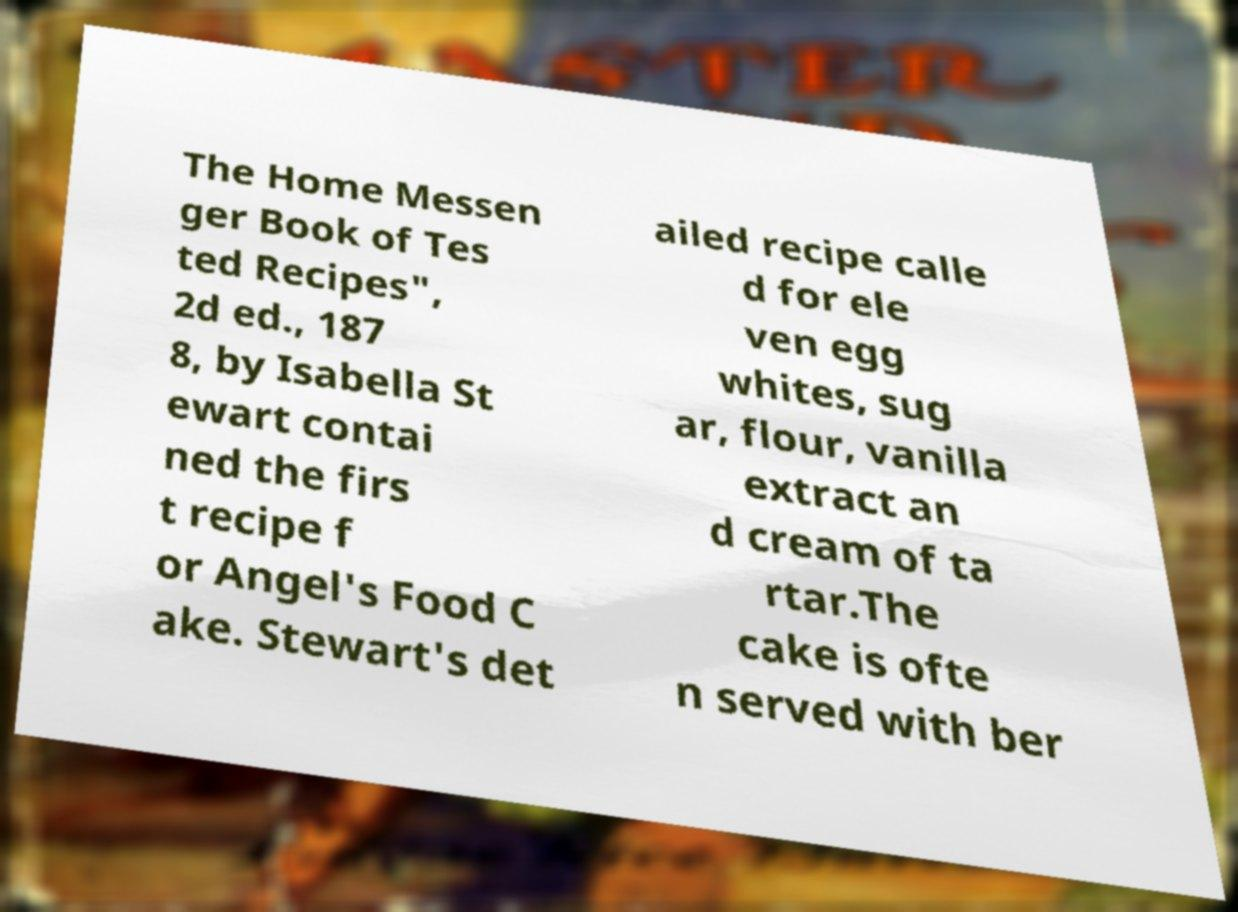Can you read and provide the text displayed in the image?This photo seems to have some interesting text. Can you extract and type it out for me? The Home Messen ger Book of Tes ted Recipes", 2d ed., 187 8, by Isabella St ewart contai ned the firs t recipe f or Angel's Food C ake. Stewart's det ailed recipe calle d for ele ven egg whites, sug ar, flour, vanilla extract an d cream of ta rtar.The cake is ofte n served with ber 